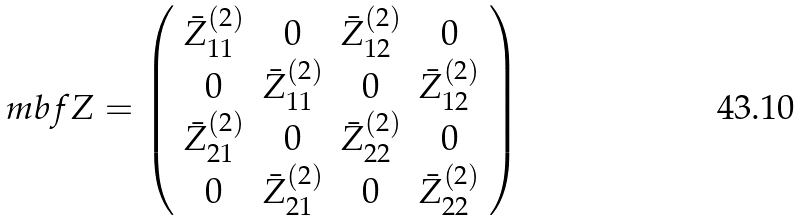Convert formula to latex. <formula><loc_0><loc_0><loc_500><loc_500>\ m b f { Z } = \left ( \begin{array} { c c c c } \bar { Z } ^ { ( 2 ) } _ { 1 1 } & 0 & \bar { Z } ^ { ( 2 ) } _ { 1 2 } & 0 \\ 0 & \bar { Z } ^ { ( 2 ) } _ { 1 1 } & 0 & \bar { Z } ^ { ( 2 ) } _ { 1 2 } \\ \bar { Z } ^ { ( 2 ) } _ { 2 1 } & 0 & \bar { Z } ^ { ( 2 ) } _ { 2 2 } & 0 \\ 0 & \bar { Z } ^ { ( 2 ) } _ { 2 1 } & 0 & \bar { Z } ^ { ( 2 ) } _ { 2 2 } \\ \end{array} \right )</formula> 